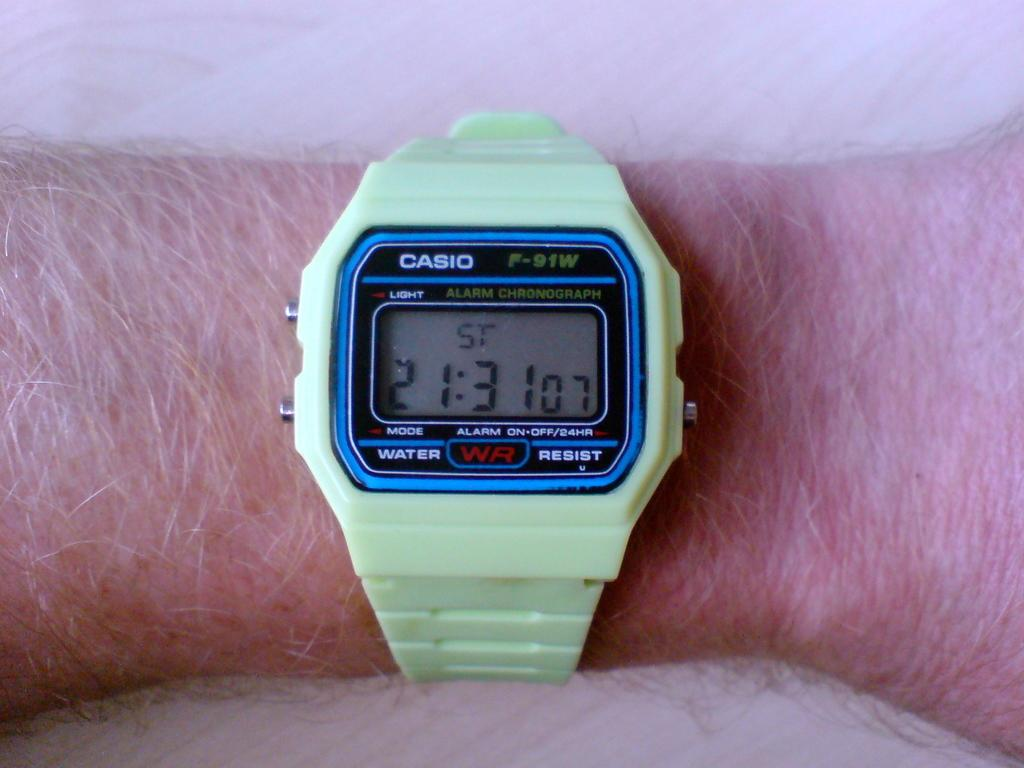<image>
Relay a brief, clear account of the picture shown. A person is wearing a green Casio watch. 